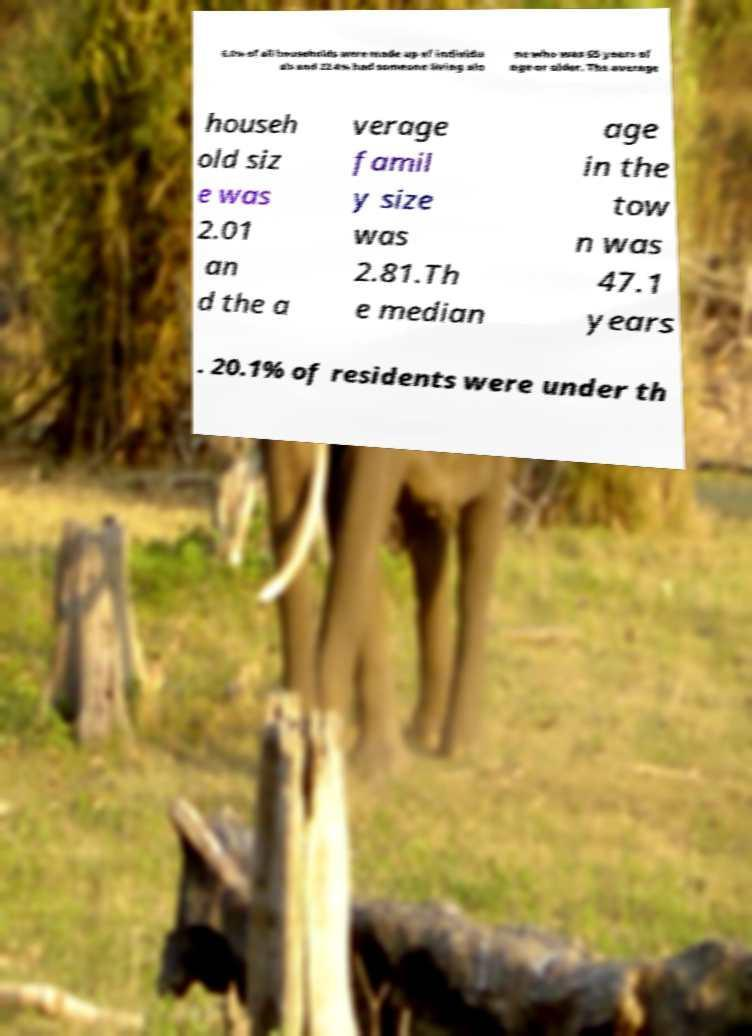Can you accurately transcribe the text from the provided image for me? 6.0% of all households were made up of individu als and 22.4% had someone living alo ne who was 65 years of age or older. The average househ old siz e was 2.01 an d the a verage famil y size was 2.81.Th e median age in the tow n was 47.1 years . 20.1% of residents were under th 